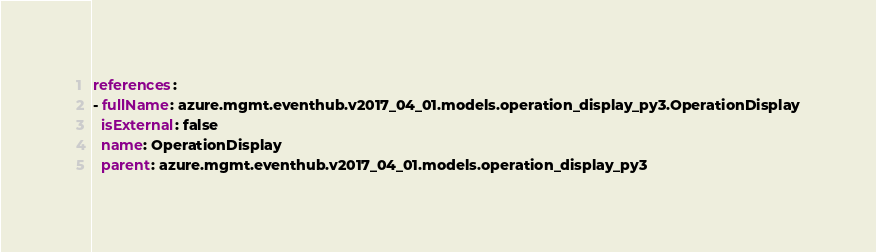<code> <loc_0><loc_0><loc_500><loc_500><_YAML_>references:
- fullName: azure.mgmt.eventhub.v2017_04_01.models.operation_display_py3.OperationDisplay
  isExternal: false
  name: OperationDisplay
  parent: azure.mgmt.eventhub.v2017_04_01.models.operation_display_py3</code> 